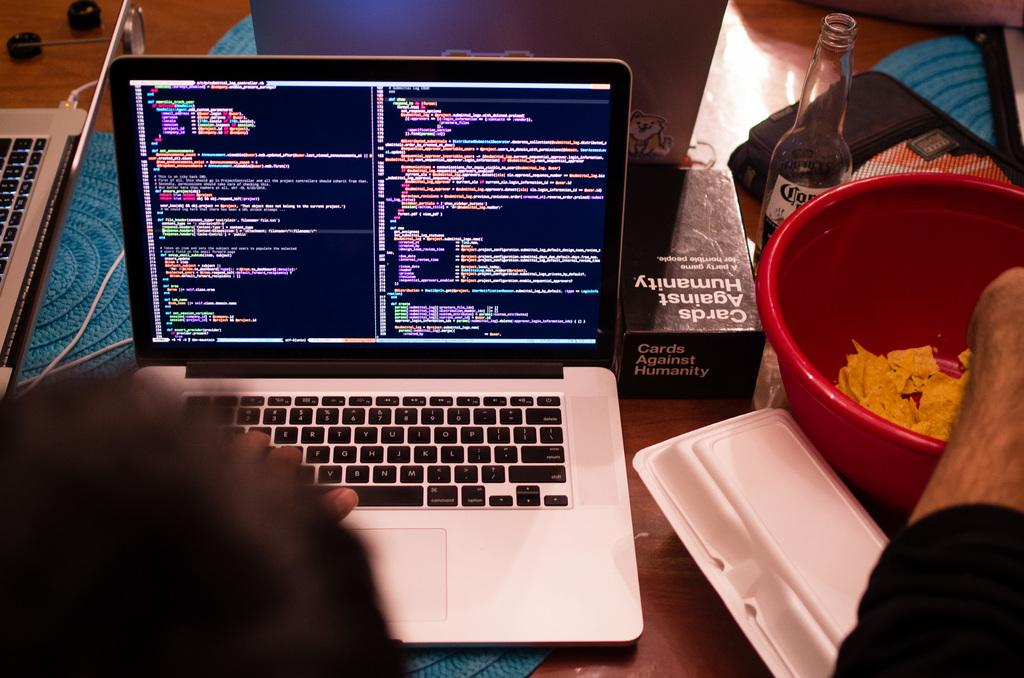<image>
Relay a brief, clear account of the picture shown. an open laptop, to the left of which is a box of the game Cards Against Humanity 